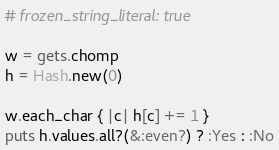<code> <loc_0><loc_0><loc_500><loc_500><_Ruby_># frozen_string_literal: true

w = gets.chomp
h = Hash.new(0)

w.each_char { |c| h[c] += 1 }
puts h.values.all?(&:even?) ? :Yes : :No</code> 